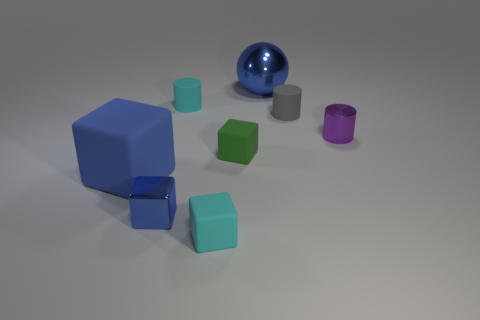There is a tiny object that is both to the left of the gray thing and behind the purple cylinder; what material is it?
Provide a succinct answer. Rubber. What is the shape of the big blue thing on the left side of the tiny cylinder left of the gray cylinder?
Offer a terse response. Cube. Is there anything else that has the same color as the shiny cube?
Give a very brief answer. Yes. There is a purple shiny cylinder; is its size the same as the blue metallic object that is to the left of the big blue metallic thing?
Offer a terse response. Yes. What number of big objects are either brown shiny balls or blue metallic balls?
Your answer should be compact. 1. Are there more big blue rubber cylinders than big matte things?
Offer a very short reply. No. How many purple things are to the left of the tiny cyan rubber object behind the cyan matte object that is in front of the shiny cube?
Give a very brief answer. 0. The purple object has what shape?
Your answer should be compact. Cylinder. How many other objects are there of the same material as the gray cylinder?
Your answer should be very brief. 4. Do the green matte block and the blue sphere have the same size?
Your answer should be compact. No. 